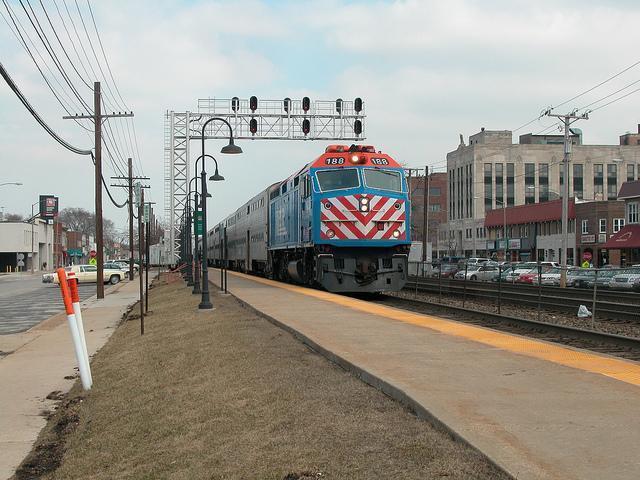How many baskets are on the left of the woman wearing stripes?
Give a very brief answer. 0. 